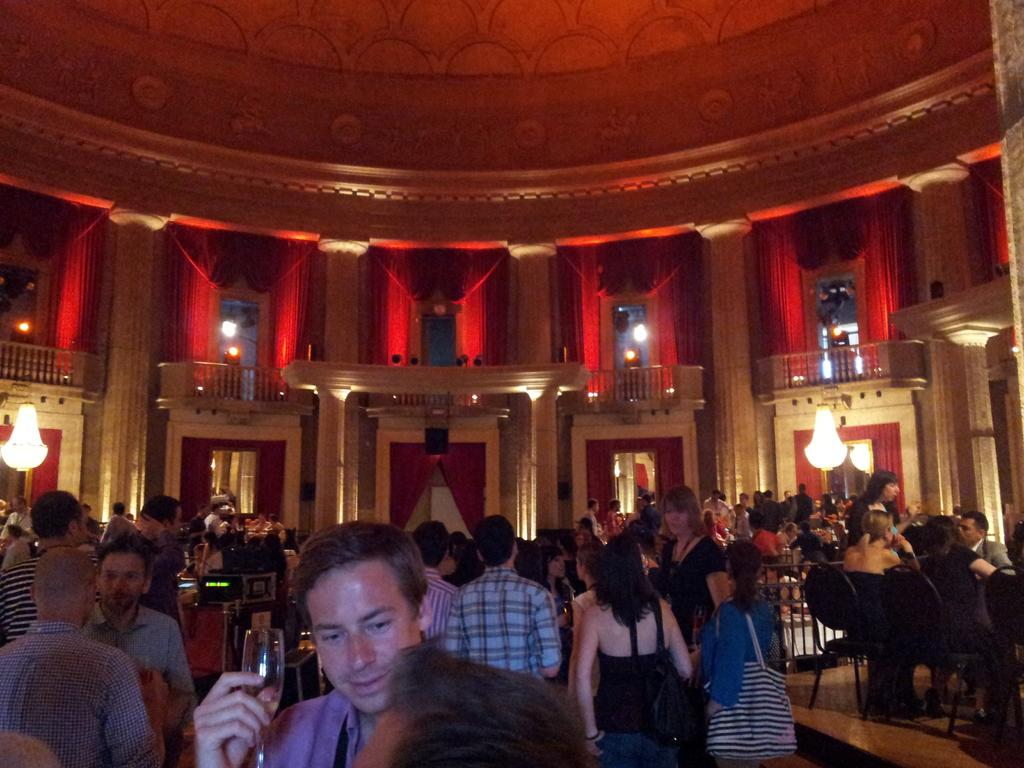What are the people in the image doing? There are people standing and sitting on chairs in the image. What can be seen in the background of the image? There are pillars, curtains, and lights in the background of the image. What is visible at the top of the image? There is a roof visible at the top of the image. How many clocks are hanging on the pillars in the image? There are no clocks visible in the image; only pillars, curtains, and lights can be seen in the background. 